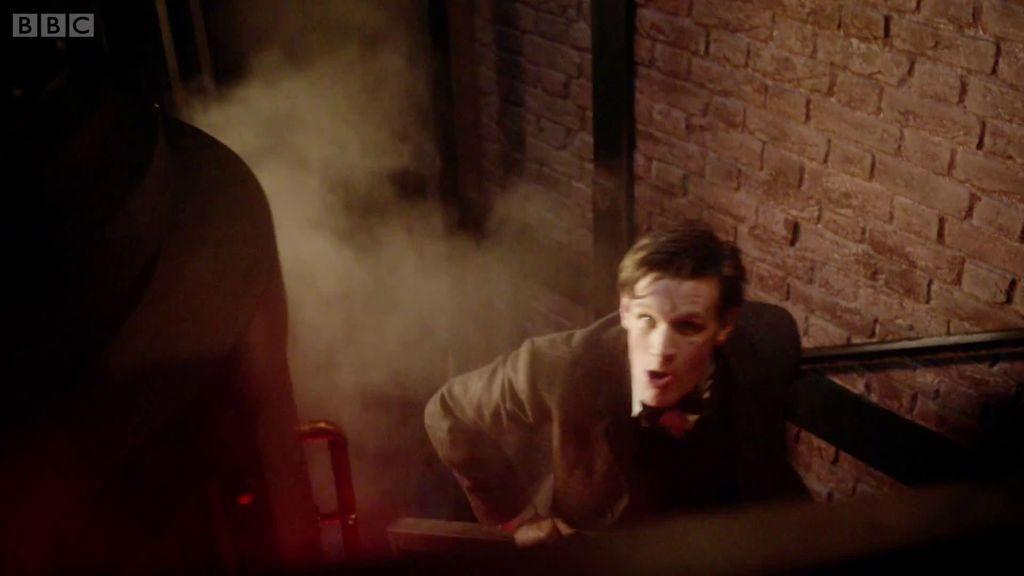Could you give a brief overview of what you see in this image? This image is taken indoors. In the background there is a brick wall. On the right side of the image a man is climbing the stairs and there is a railing. 